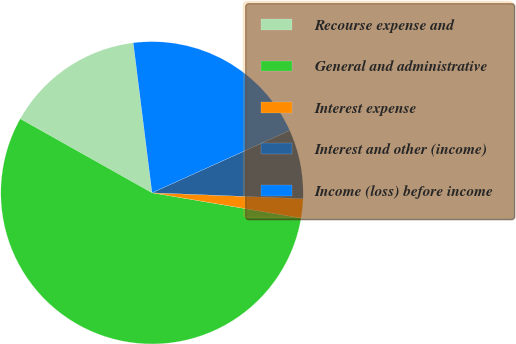Convert chart to OTSL. <chart><loc_0><loc_0><loc_500><loc_500><pie_chart><fcel>Recourse expense and<fcel>General and administrative<fcel>Interest expense<fcel>Interest and other (income)<fcel>Income (loss) before income<nl><fcel>14.87%<fcel>55.47%<fcel>2.05%<fcel>7.39%<fcel>20.21%<nl></chart> 